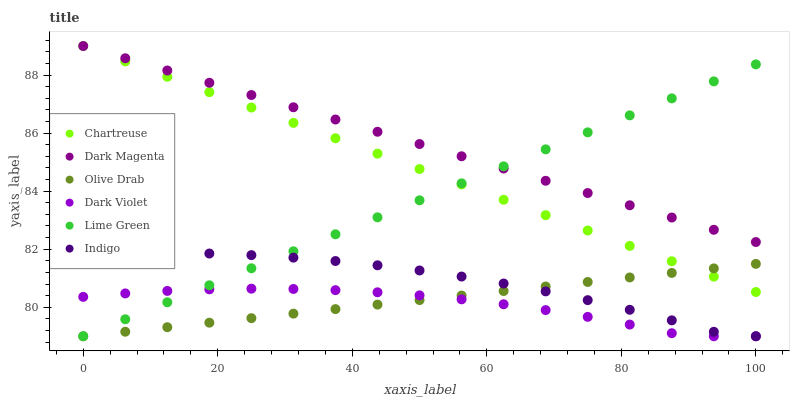Does Dark Violet have the minimum area under the curve?
Answer yes or no. Yes. Does Dark Magenta have the maximum area under the curve?
Answer yes or no. Yes. Does Dark Magenta have the minimum area under the curve?
Answer yes or no. No. Does Dark Violet have the maximum area under the curve?
Answer yes or no. No. Is Dark Magenta the smoothest?
Answer yes or no. Yes. Is Dark Violet the roughest?
Answer yes or no. Yes. Is Dark Violet the smoothest?
Answer yes or no. No. Is Dark Magenta the roughest?
Answer yes or no. No. Does Indigo have the lowest value?
Answer yes or no. Yes. Does Dark Magenta have the lowest value?
Answer yes or no. No. Does Chartreuse have the highest value?
Answer yes or no. Yes. Does Dark Violet have the highest value?
Answer yes or no. No. Is Dark Violet less than Chartreuse?
Answer yes or no. Yes. Is Chartreuse greater than Dark Violet?
Answer yes or no. Yes. Does Lime Green intersect Dark Violet?
Answer yes or no. Yes. Is Lime Green less than Dark Violet?
Answer yes or no. No. Is Lime Green greater than Dark Violet?
Answer yes or no. No. Does Dark Violet intersect Chartreuse?
Answer yes or no. No. 